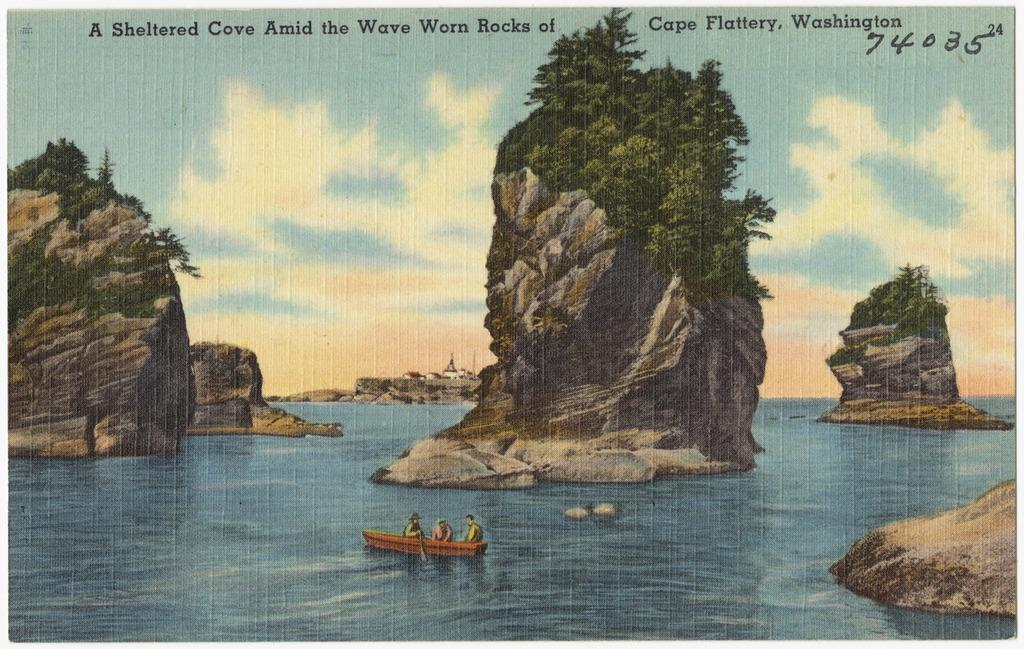What type of visual representation is shown in the image? The image is a poster. What natural elements can be seen in the image? There are rocks and trees in the image. What activity is taking place in the image? There are people sailing a boat in the water. What is the primary source of water in the image? The water is visible in the image. What can be seen in the background of the image? There is a sky in the background of the image. Where is the zebra grazing in the image? There is no zebra present in the image. What type of camp can be seen in the image? There is no camp present in the image. 